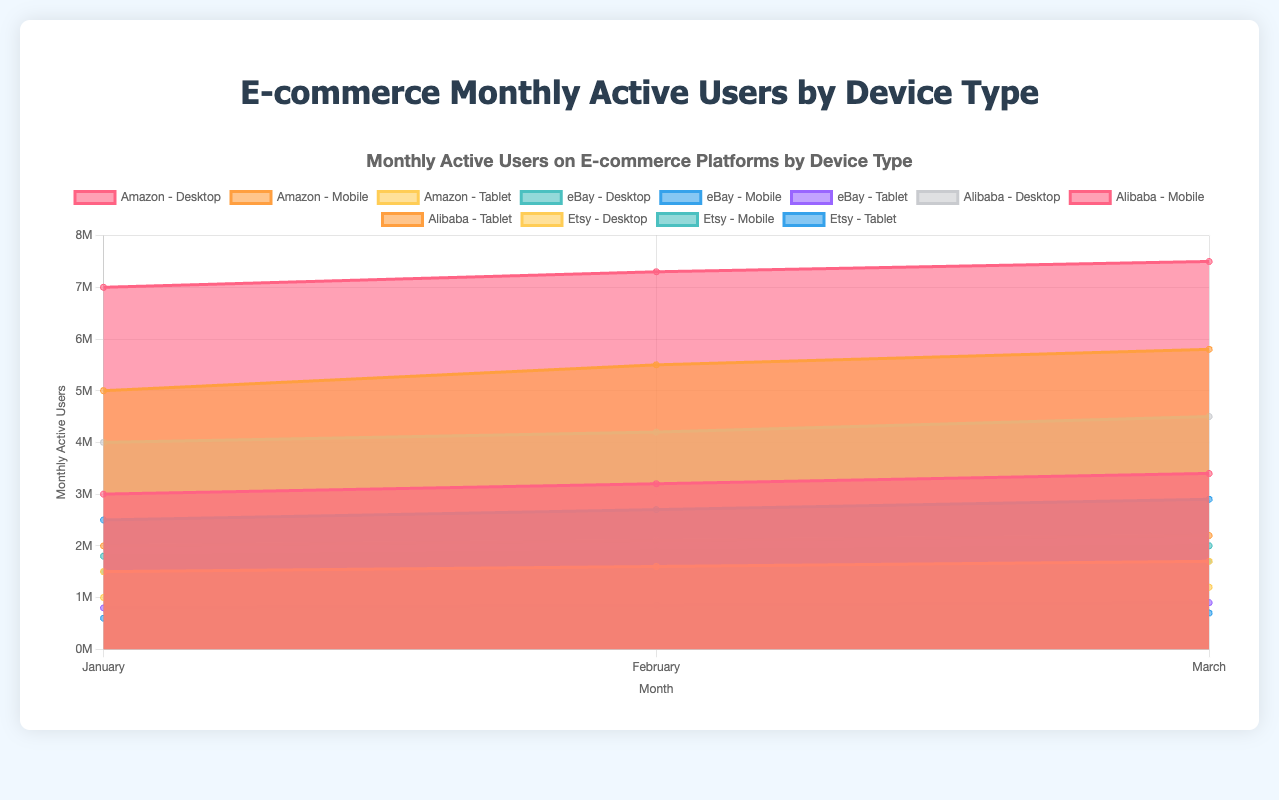What's the title of the chart? The chart largely contains a title at the top that describes the purpose of the visualization. It's written as part of the visual elements that usually provide an overview context for the chart.
Answer: E-commerce Monthly Active Users by Device Type What are the three devices compared in the chart? The chart compares the usage of different devices; these devices are listed individually in the legend and are distinguished by their colors.
Answer: Desktop, Mobile, Tablet Which platform had the highest number of mobile users in March? To find this, you'll look at the “Mobile” data points for all platforms in March and compare them. The one with the highest value among Amazon, eBay, Alibaba, and Etsy will be the answer.
Answer: Alibaba What is the trend of desktop users for Amazon from January to March? To observe the trends on the chart, you can follow the "Desktop" data line for Amazon across the three months. Observing whether it is increasing, decreasing, or stable is key to understanding the pattern.
Answer: Increasing What is the total number of monthly active users for Alibaba in February across all devices? To find this total, you sum up the "Desktop," "Mobile," and "Tablet" users for Alibaba in February. The exact numbers are provided on the chart so it's just basic addition.
Answer: 13,600,000 Which device type has the most consistent (least variable) usage for eBay from January to March? Examining the eBay data, look at the three device types and observe the fluctuation over the three months. The device with the least change in user numbers is seen as most consistent.
Answer: Tablet How does the number of mobile users on Etsy in March compare to the desktop users on the same platform? You'll need to reference both the mobile and desktop figures for Etsy in March. This is a comparison question to see if one is greater than the other.
Answer: Mobile users are greater Which platform shows the highest increase in desktop users from January to March? For this, you'll compare the values of "Desktop" users from January and March across all platforms and identify the platform with the largest numerical increase.
Answer: Alibaba What percentage of Amazon's total users in March is using tablets? Sum up the number of users across Desktop, Mobile, and Tablet for Amazon in March. Then divide the tablet users by this sum and multiply by 100 to get the percentage. This is a compositional question requiring basic arithmetic and percentage calculation.
Answer: 12.74% 